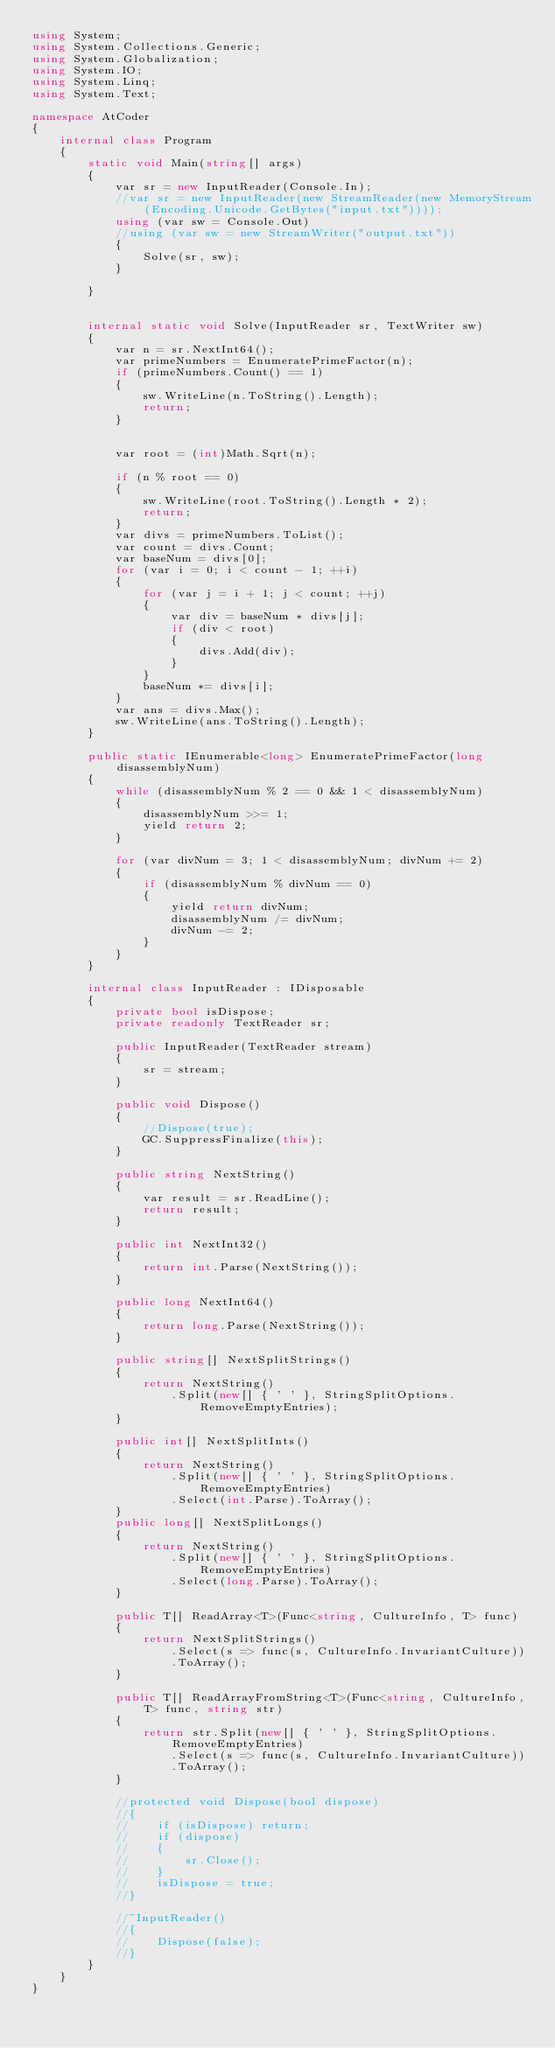Convert code to text. <code><loc_0><loc_0><loc_500><loc_500><_C#_>using System;
using System.Collections.Generic;
using System.Globalization;
using System.IO;
using System.Linq;
using System.Text;

namespace AtCoder
{
    internal class Program
    {
        static void Main(string[] args)
        {
            var sr = new InputReader(Console.In);
            //var sr = new InputReader(new StreamReader(new MemoryStream(Encoding.Unicode.GetBytes("input.txt"))));
            using (var sw = Console.Out)
            //using (var sw = new StreamWriter("output.txt"))
            {
                Solve(sr, sw);
            }

        }


        internal static void Solve(InputReader sr, TextWriter sw)
        {
            var n = sr.NextInt64();
            var primeNumbers = EnumeratePrimeFactor(n);
            if (primeNumbers.Count() == 1)
            {
                sw.WriteLine(n.ToString().Length);
                return;
            }


            var root = (int)Math.Sqrt(n);

            if (n % root == 0)
            {
                sw.WriteLine(root.ToString().Length * 2);
                return;
            }
            var divs = primeNumbers.ToList();
            var count = divs.Count;
            var baseNum = divs[0];
            for (var i = 0; i < count - 1; ++i)
            {
                for (var j = i + 1; j < count; ++j)
                {
                    var div = baseNum * divs[j];
                    if (div < root)
                    {
                        divs.Add(div);
                    }
                }
                baseNum *= divs[i];
            }
            var ans = divs.Max();
            sw.WriteLine(ans.ToString().Length);
        }

        public static IEnumerable<long> EnumeratePrimeFactor(long disassemblyNum)
        {
            while (disassemblyNum % 2 == 0 && 1 < disassemblyNum)
            {
                disassemblyNum >>= 1;
                yield return 2;
            }

            for (var divNum = 3; 1 < disassemblyNum; divNum += 2)
            {
                if (disassemblyNum % divNum == 0)
                {
                    yield return divNum;
                    disassemblyNum /= divNum;
                    divNum -= 2;
                }
            }
        }

        internal class InputReader : IDisposable
        {
            private bool isDispose;
            private readonly TextReader sr;

            public InputReader(TextReader stream)
            {
                sr = stream;
            }

            public void Dispose()
            {
                //Dispose(true);
                GC.SuppressFinalize(this);
            }

            public string NextString()
            {
                var result = sr.ReadLine();
                return result;
            }

            public int NextInt32()
            {
                return int.Parse(NextString());
            }

            public long NextInt64()
            {
                return long.Parse(NextString());
            }

            public string[] NextSplitStrings()
            {
                return NextString()
                    .Split(new[] { ' ' }, StringSplitOptions.RemoveEmptyEntries);
            }

            public int[] NextSplitInts()
            {
                return NextString()
                    .Split(new[] { ' ' }, StringSplitOptions.RemoveEmptyEntries)
                    .Select(int.Parse).ToArray();
            }
            public long[] NextSplitLongs()
            {
                return NextString()
                    .Split(new[] { ' ' }, StringSplitOptions.RemoveEmptyEntries)
                    .Select(long.Parse).ToArray();
            }

            public T[] ReadArray<T>(Func<string, CultureInfo, T> func)
            {
                return NextSplitStrings()
                    .Select(s => func(s, CultureInfo.InvariantCulture))
                    .ToArray();
            }

            public T[] ReadArrayFromString<T>(Func<string, CultureInfo, T> func, string str)
            {
                return str.Split(new[] { ' ' }, StringSplitOptions.RemoveEmptyEntries)
                    .Select(s => func(s, CultureInfo.InvariantCulture))
                    .ToArray();
            }

            //protected void Dispose(bool dispose)
            //{
            //    if (isDispose) return;
            //    if (dispose)
            //    {
            //        sr.Close();
            //    }
            //    isDispose = true;
            //}

            //~InputReader()
            //{
            //    Dispose(false);
            //}
        }
    }
}</code> 